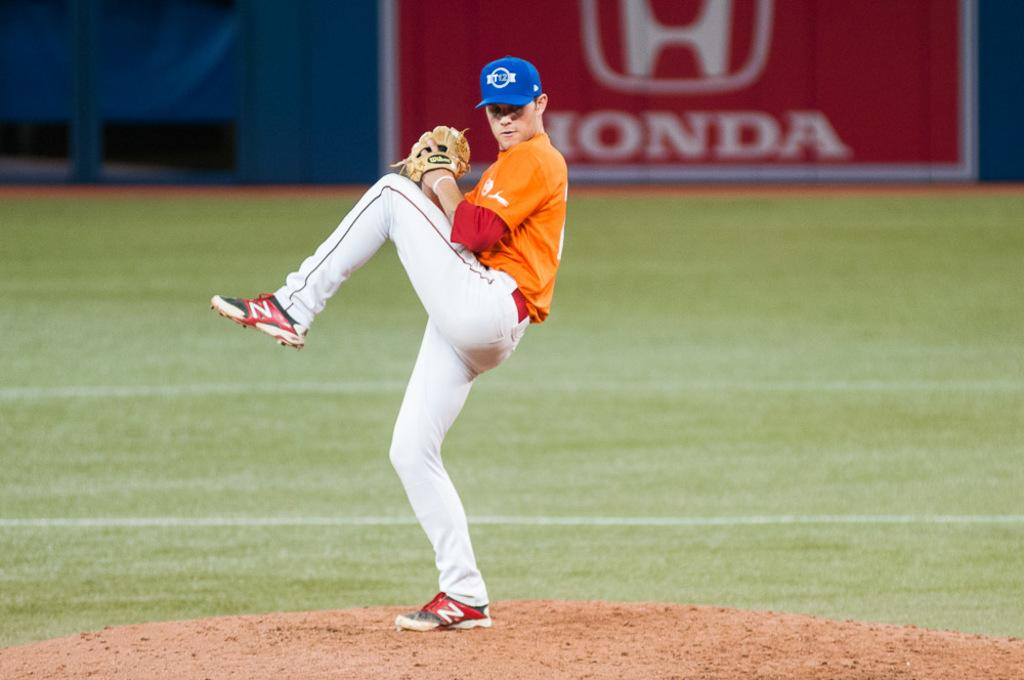Provide a one-sentence caption for the provided image. A pitcher prepares to throw the ball in front of a big red Honda sign. 